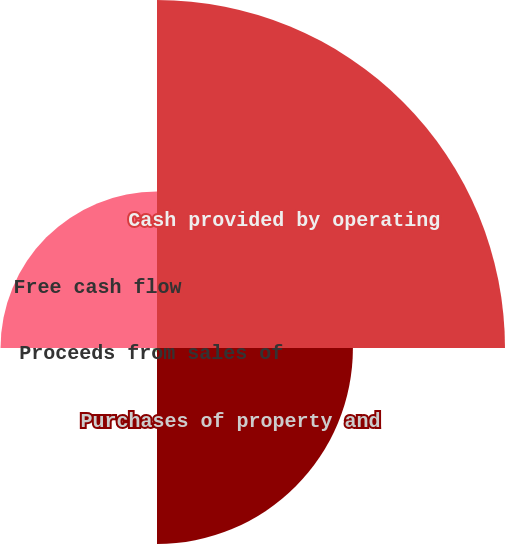Convert chart to OTSL. <chart><loc_0><loc_0><loc_500><loc_500><pie_chart><fcel>Cash provided by operating<fcel>Purchases of property and<fcel>Proceeds from sales of<fcel>Free cash flow<nl><fcel>49.38%<fcel>27.8%<fcel>0.62%<fcel>22.2%<nl></chart> 